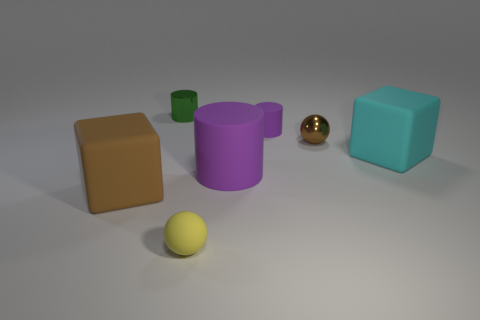How many things are blue metal balls or cylinders that are right of the small green object?
Your answer should be very brief. 2. Are there any green things that have the same shape as the brown matte thing?
Provide a short and direct response. No. How big is the block on the right side of the brown object in front of the big matte block that is right of the tiny purple rubber thing?
Your answer should be compact. Large. Are there an equal number of large cyan blocks behind the small green metal object and tiny brown things that are to the left of the tiny brown thing?
Provide a short and direct response. Yes. What size is the cylinder that is made of the same material as the brown ball?
Your answer should be compact. Small. The tiny rubber cylinder has what color?
Your answer should be very brief. Purple. What number of small rubber cylinders have the same color as the large cylinder?
Provide a succinct answer. 1. What is the material of the purple cylinder that is the same size as the yellow object?
Your response must be concise. Rubber. There is a object on the left side of the green metallic cylinder; are there any tiny rubber cylinders behind it?
Ensure brevity in your answer.  Yes. What number of other objects are there of the same color as the rubber sphere?
Offer a terse response. 0. 